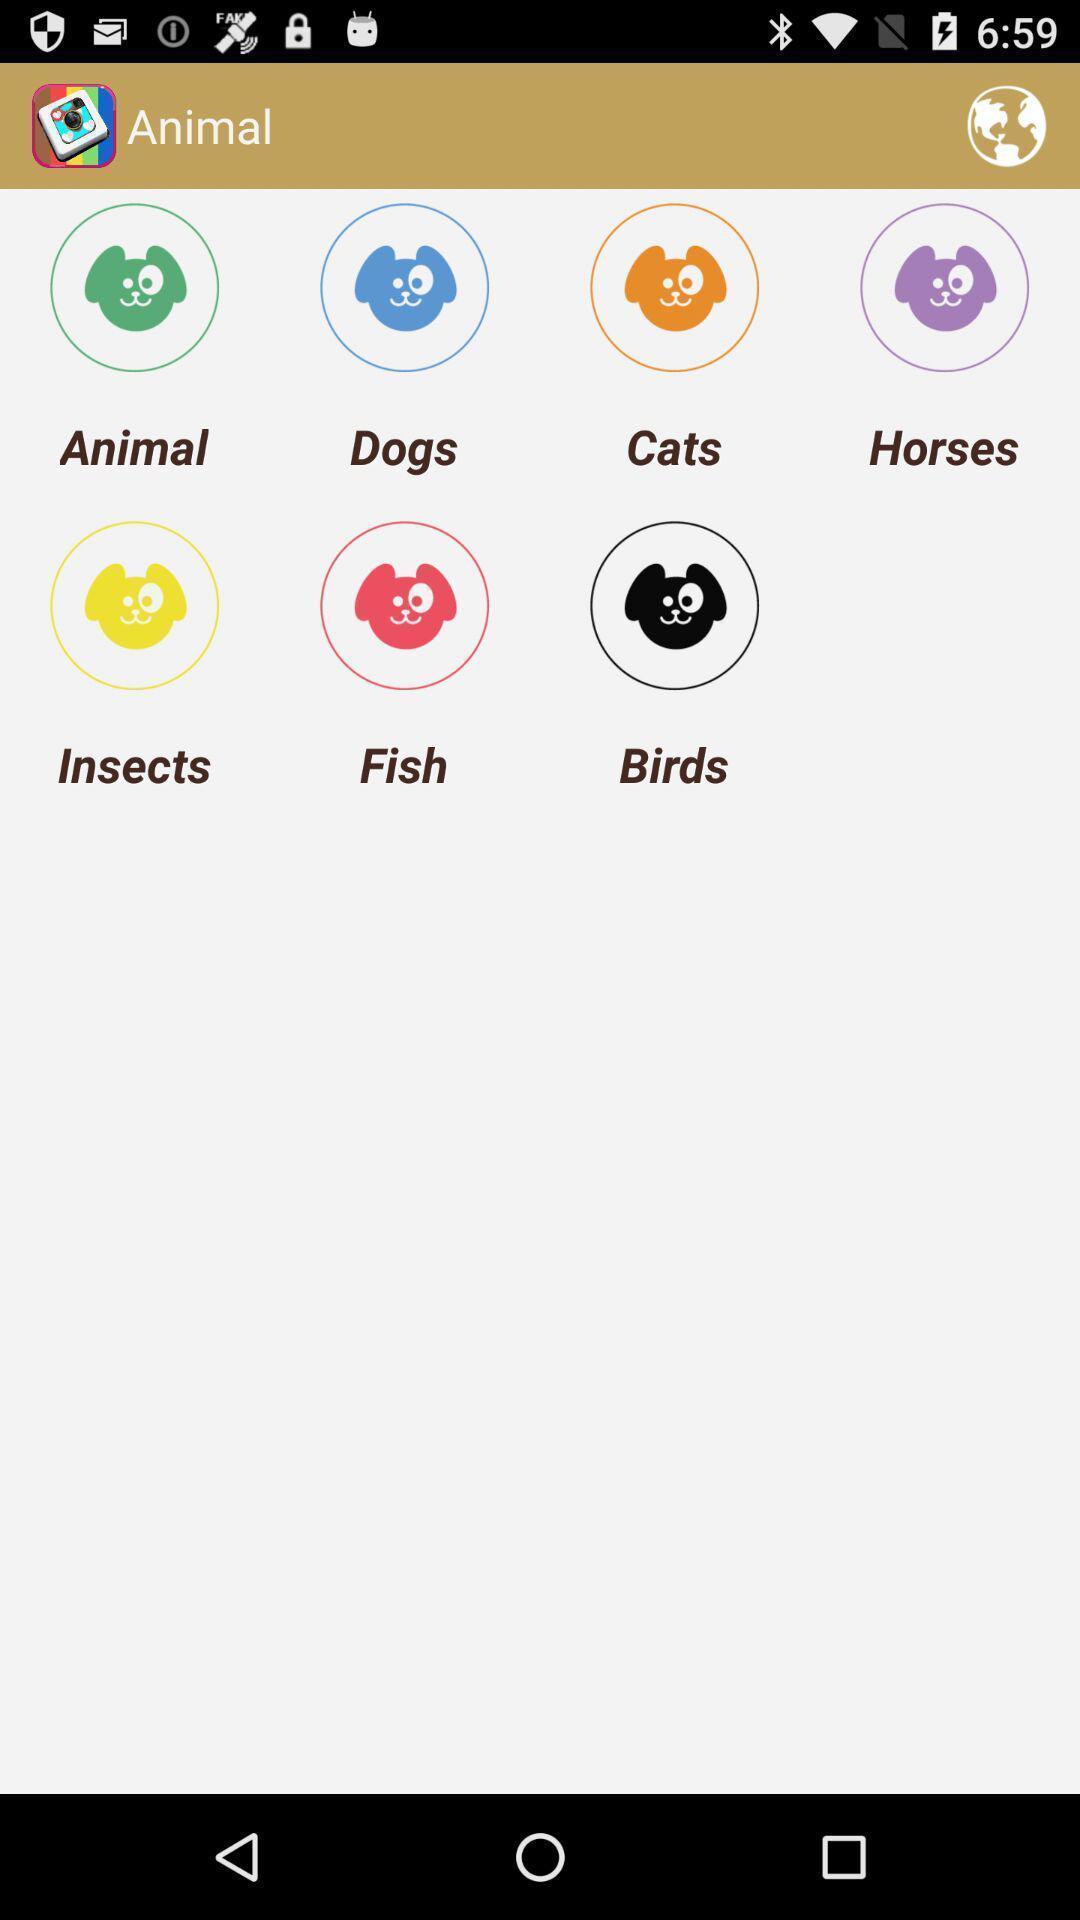Describe this image in words. Various categories of animals in a painting app. 